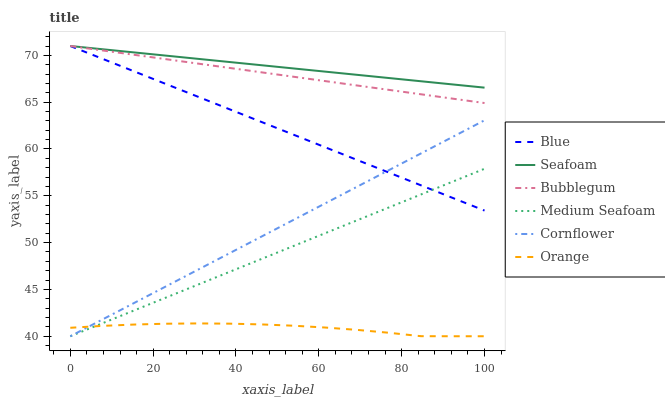Does Orange have the minimum area under the curve?
Answer yes or no. Yes. Does Seafoam have the maximum area under the curve?
Answer yes or no. Yes. Does Cornflower have the minimum area under the curve?
Answer yes or no. No. Does Cornflower have the maximum area under the curve?
Answer yes or no. No. Is Blue the smoothest?
Answer yes or no. Yes. Is Orange the roughest?
Answer yes or no. Yes. Is Cornflower the smoothest?
Answer yes or no. No. Is Cornflower the roughest?
Answer yes or no. No. Does Cornflower have the lowest value?
Answer yes or no. Yes. Does Seafoam have the lowest value?
Answer yes or no. No. Does Bubblegum have the highest value?
Answer yes or no. Yes. Does Cornflower have the highest value?
Answer yes or no. No. Is Cornflower less than Seafoam?
Answer yes or no. Yes. Is Seafoam greater than Orange?
Answer yes or no. Yes. Does Seafoam intersect Bubblegum?
Answer yes or no. Yes. Is Seafoam less than Bubblegum?
Answer yes or no. No. Is Seafoam greater than Bubblegum?
Answer yes or no. No. Does Cornflower intersect Seafoam?
Answer yes or no. No. 